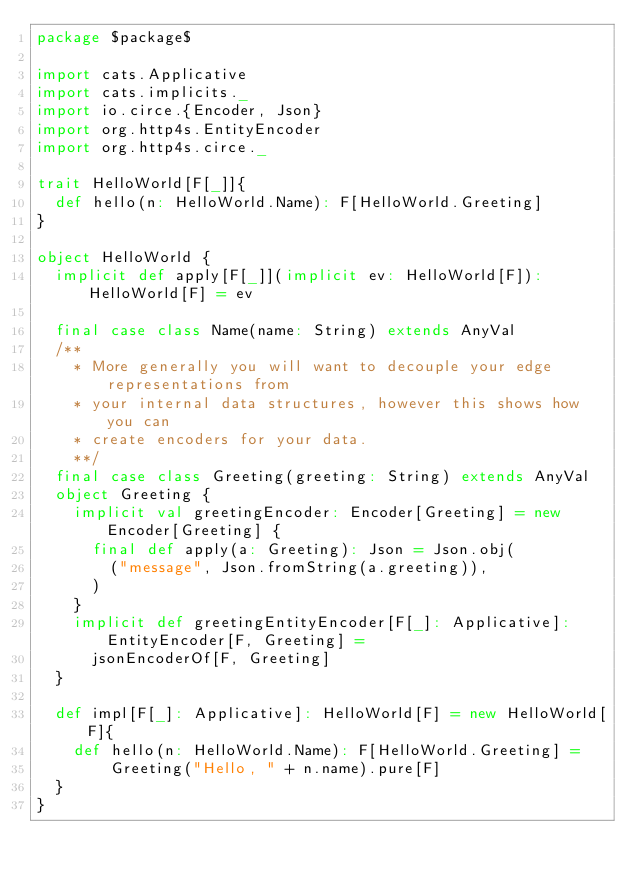Convert code to text. <code><loc_0><loc_0><loc_500><loc_500><_Scala_>package $package$

import cats.Applicative
import cats.implicits._
import io.circe.{Encoder, Json}
import org.http4s.EntityEncoder
import org.http4s.circe._

trait HelloWorld[F[_]]{
  def hello(n: HelloWorld.Name): F[HelloWorld.Greeting]
}

object HelloWorld {
  implicit def apply[F[_]](implicit ev: HelloWorld[F]): HelloWorld[F] = ev

  final case class Name(name: String) extends AnyVal
  /**
    * More generally you will want to decouple your edge representations from
    * your internal data structures, however this shows how you can
    * create encoders for your data.
    **/
  final case class Greeting(greeting: String) extends AnyVal
  object Greeting {
    implicit val greetingEncoder: Encoder[Greeting] = new Encoder[Greeting] {
      final def apply(a: Greeting): Json = Json.obj(
        ("message", Json.fromString(a.greeting)),
      )
    }
    implicit def greetingEntityEncoder[F[_]: Applicative]: EntityEncoder[F, Greeting] =
      jsonEncoderOf[F, Greeting]
  }

  def impl[F[_]: Applicative]: HelloWorld[F] = new HelloWorld[F]{
    def hello(n: HelloWorld.Name): F[HelloWorld.Greeting] =
        Greeting("Hello, " + n.name).pure[F]
  }
}</code> 